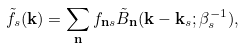<formula> <loc_0><loc_0><loc_500><loc_500>\tilde { f } _ { s } ( { \mathbf k } ) = \sum _ { \mathbf n } f _ { { \mathbf n } s } \tilde { B } _ { \mathbf n } ( { \mathbf k } - { \mathbf k } _ { s } ; \beta _ { s } ^ { - 1 } ) ,</formula> 